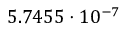<formula> <loc_0><loc_0><loc_500><loc_500>5 . 7 4 5 5 \cdot 1 0 ^ { - 7 }</formula> 